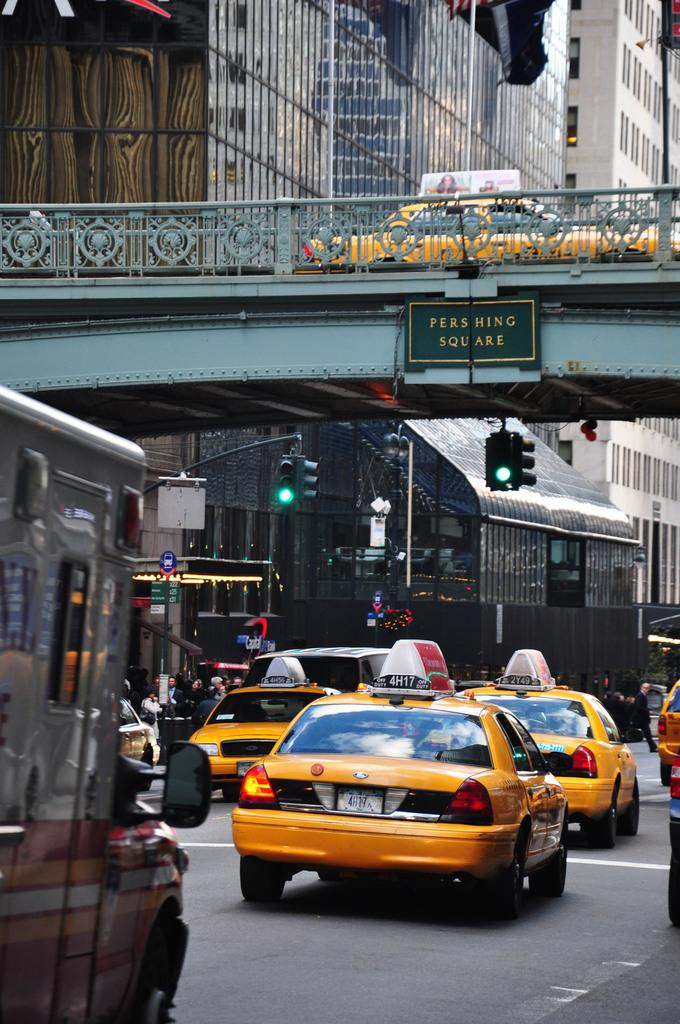<image>
Summarize the visual content of the image. Three yellow taxi cab cars with signs on top in city limit. 